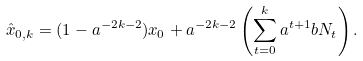<formula> <loc_0><loc_0><loc_500><loc_500>\hat { x } _ { 0 , k } = ( 1 - a ^ { - 2 k - 2 } ) x _ { 0 } + a ^ { - 2 k - 2 } \left ( \sum _ { t = 0 } ^ { k } a ^ { t + 1 } b N _ { t } \right ) .</formula> 